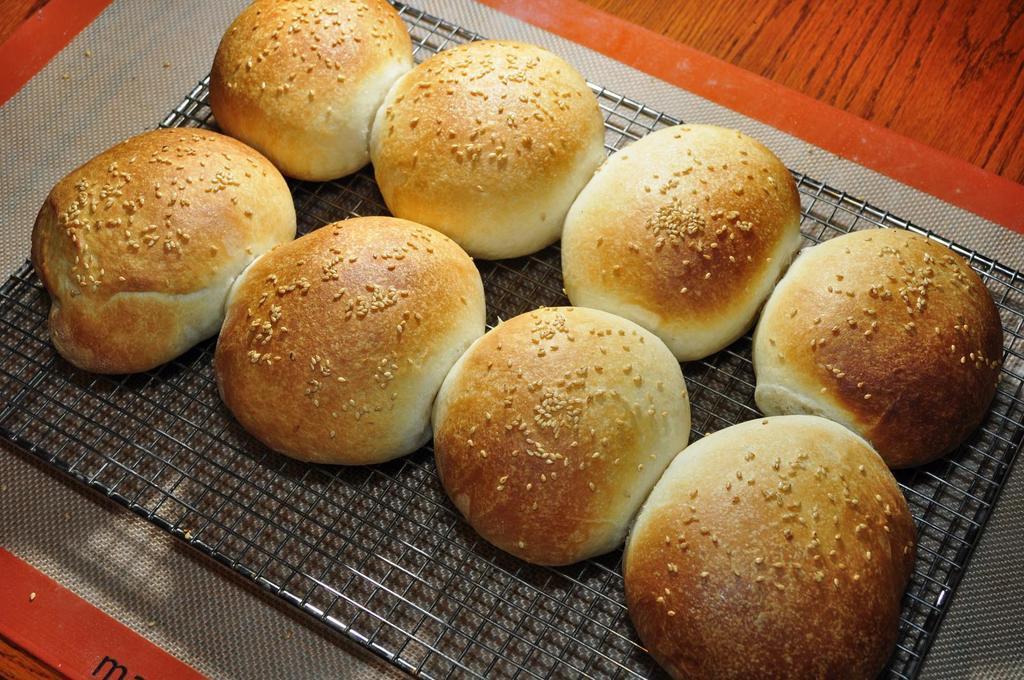Could you give a brief overview of what you see in this image? In this image we can see the buns on the grill which is on the table. 